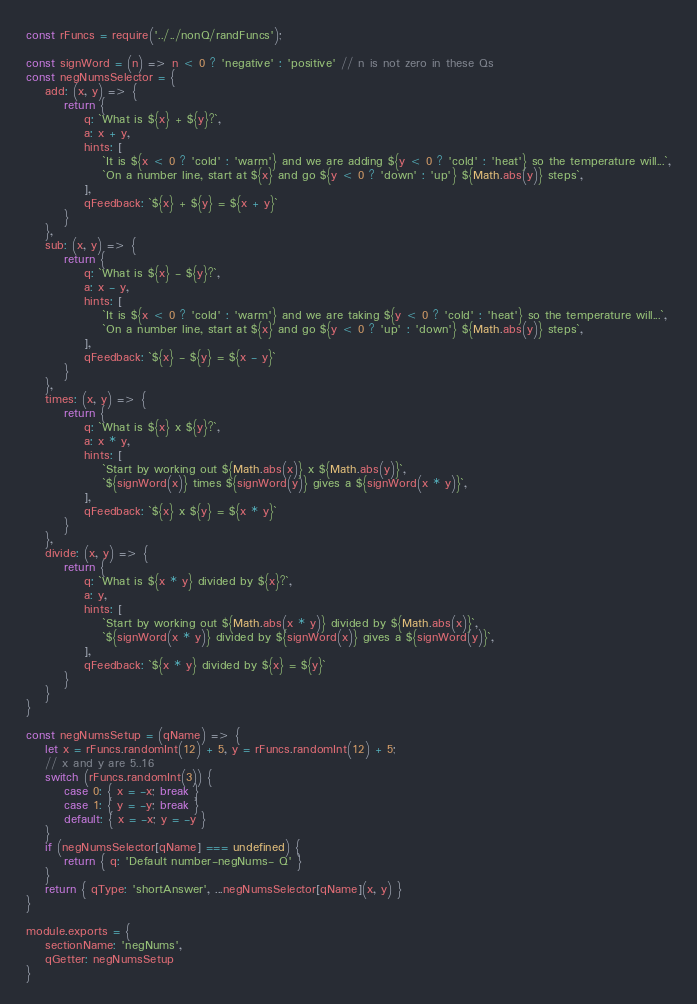<code> <loc_0><loc_0><loc_500><loc_500><_JavaScript_>const rFuncs = require('../../nonQ/randFuncs');

const signWord = (n) => n < 0 ? 'negative' : 'positive' // n is not zero in these Qs
const negNumsSelector = {
    add: (x, y) => {
        return {
            q: `What is ${x} + ${y}?`,
            a: x + y,
            hints: [
                `It is ${x < 0 ? 'cold' : 'warm'} and we are adding ${y < 0 ? 'cold' : 'heat'} so the temperature will...`,
                `On a number line, start at ${x} and go ${y < 0 ? 'down' : 'up'} ${Math.abs(y)} steps`,
            ],
            qFeedback: `${x} + ${y} = ${x + y}`
        }
    },
    sub: (x, y) => {
        return {
            q: `What is ${x} - ${y}?`,
            a: x - y,
            hints: [
                `It is ${x < 0 ? 'cold' : 'warm'} and we are taking ${y < 0 ? 'cold' : 'heat'} so the temperature will...`,
                `On a number line, start at ${x} and go ${y < 0 ? 'up' : 'down'} ${Math.abs(y)} steps`,
            ],
            qFeedback: `${x} - ${y} = ${x - y}`
        }
    },
    times: (x, y) => {
        return {
            q: `What is ${x} x ${y}?`,
            a: x * y,
            hints: [
                `Start by working out ${Math.abs(x)} x ${Math.abs(y)}`,
                `${signWord(x)} times ${signWord(y)} gives a ${signWord(x * y)}`,
            ],
            qFeedback: `${x} x ${y} = ${x * y}`
        }
    },
    divide: (x, y) => {
        return {
            q: `What is ${x * y} divided by ${x}?`,
            a: y,
            hints: [
                `Start by working out ${Math.abs(x * y)} divided by ${Math.abs(x)}`,
                `${signWord(x * y)} divided by ${signWord(x)} gives a ${signWord(y)}`,
            ],
            qFeedback: `${x * y} divided by ${x} = ${y}`
        }
    }
}

const negNumsSetup = (qName) => {
    let x = rFuncs.randomInt(12) + 5, y = rFuncs.randomInt(12) + 5;
    // x and y are 5..16
    switch (rFuncs.randomInt(3)) {
        case 0: { x = -x; break }
        case 1: { y = -y; break }
        default: { x = -x; y = -y }
    }
    if (negNumsSelector[qName] === undefined) {
        return { q: 'Default number-negNums- Q' }
    }
    return { qType: 'shortAnswer', ...negNumsSelector[qName](x, y) }
}

module.exports = {
    sectionName: 'negNums',
    qGetter: negNumsSetup
}</code> 